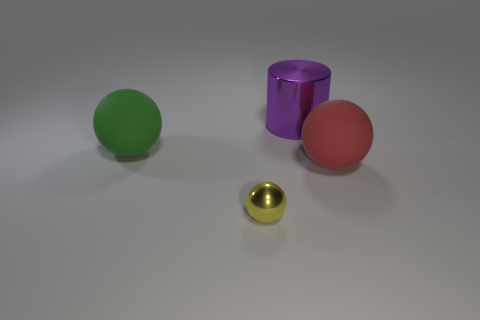Is the color of the small metallic object the same as the rubber ball left of the red ball?
Keep it short and to the point. No. How many other things are there of the same material as the green object?
Keep it short and to the point. 1. There is a object that is the same material as the small yellow ball; what is its shape?
Give a very brief answer. Cylinder. Is there anything else of the same color as the tiny metal ball?
Your answer should be very brief. No. Is the number of tiny things that are right of the big purple cylinder greater than the number of small metal objects?
Provide a succinct answer. No. Does the green rubber object have the same shape as the shiny object that is to the left of the large purple cylinder?
Provide a succinct answer. Yes. What number of gray rubber balls are the same size as the green ball?
Your response must be concise. 0. There is a rubber ball in front of the sphere that is on the left side of the small yellow ball; what number of tiny spheres are in front of it?
Provide a succinct answer. 1. Are there an equal number of small yellow shiny objects behind the large red object and yellow metallic spheres that are right of the big green matte sphere?
Offer a terse response. No. How many tiny things are the same shape as the big shiny thing?
Keep it short and to the point. 0. 